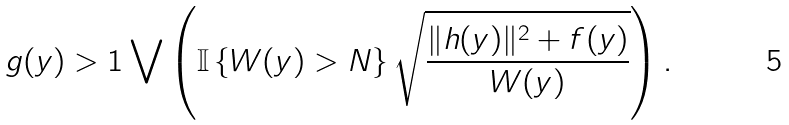Convert formula to latex. <formula><loc_0><loc_0><loc_500><loc_500>g ( y ) > 1 \bigvee \left ( \mathbb { I } \left \{ W ( y ) > N \right \} \sqrt { \frac { \| h ( y ) \| ^ { 2 } + f ( y ) } { W ( y ) } } \right ) .</formula> 